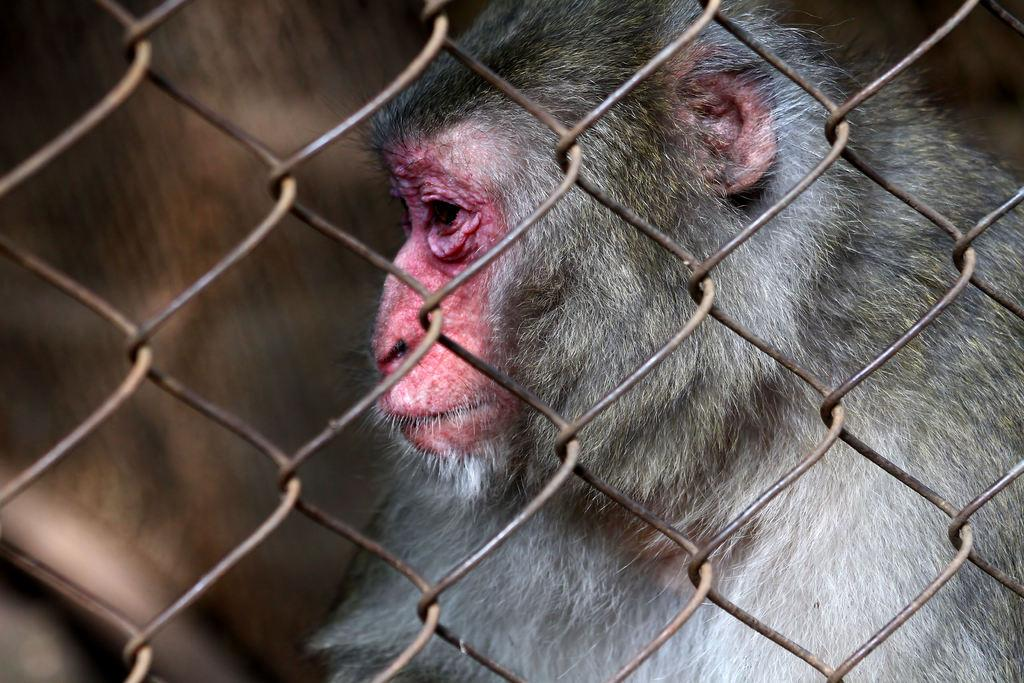What is present in the image that has a mesh-like appearance? There is a mesh in the image. What can be seen behind the mesh? There is a monkey behind the mesh. What type of clouds can be seen in the image? There are no clouds present in the image; it features a mesh and a monkey behind it. Is there a square-shaped object in the image? There is no square-shaped object mentioned in the provided facts. 